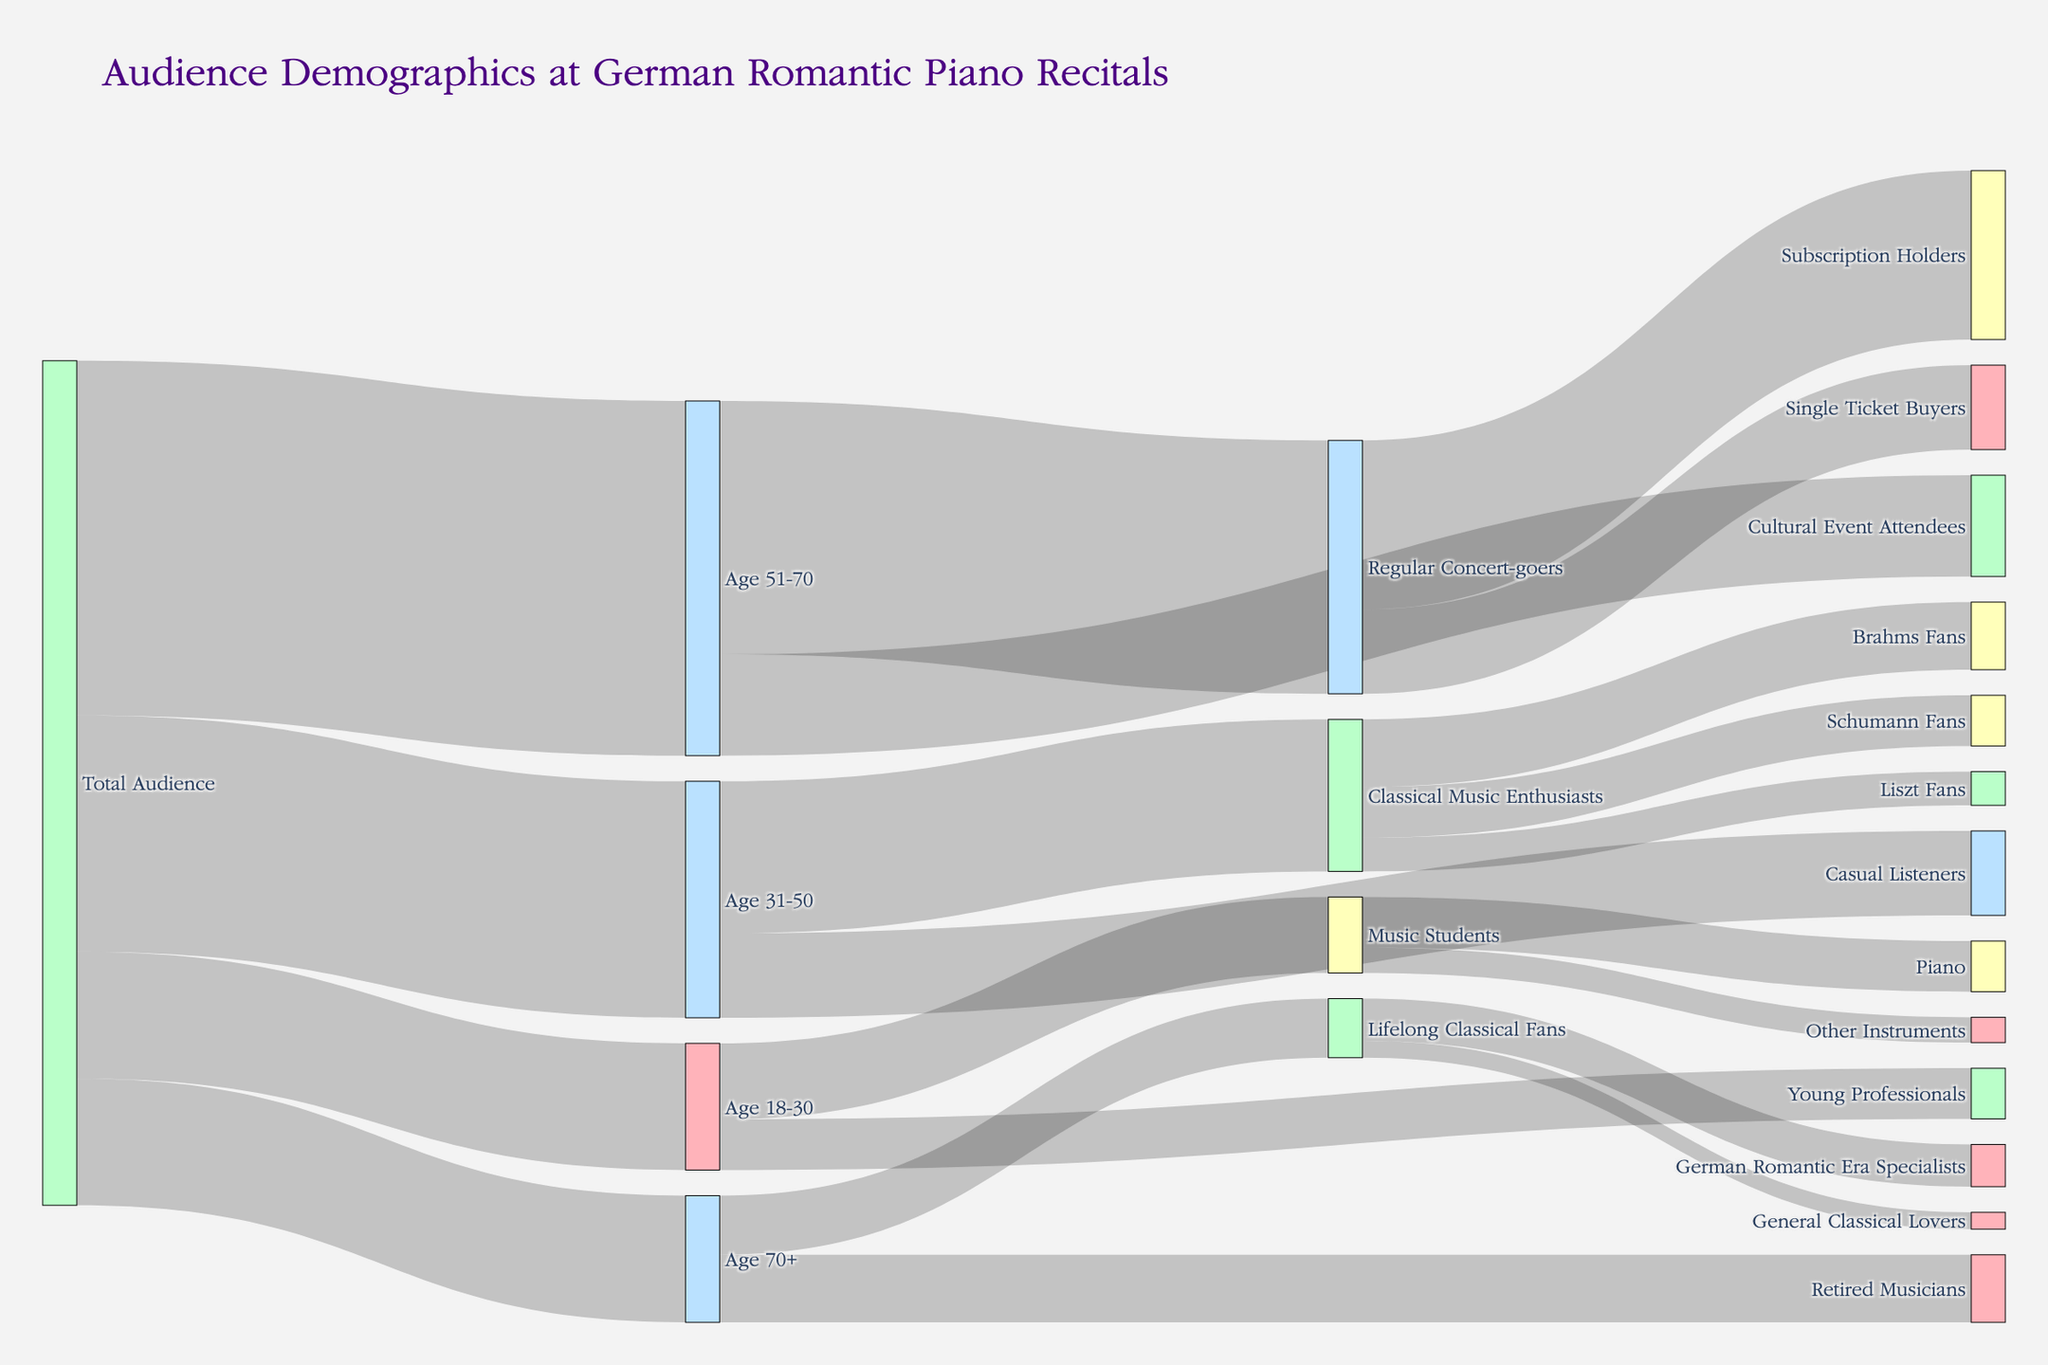What's the title of the diagram? Look at the top of the diagram where the title is usually placed. It reads "Audience Demographics at German Romantic Piano Recitals".
Answer: Audience Demographics at German Romantic Piano Recitals How many total audience members are there? The total audience members can be calculated by summing up all initial branches emanating from "Total Audience". These values are 150 + 280 + 420 + 150.
Answer: 1000 Which age group has the highest number of audience members? Examine the branches connected to "Total Audience" and compare their values. "Age 51-70" with a value of 420 has the highest.
Answer: Age 51-70 Among the "Age 31-50" group, which subgroup has more members: Classical Music Enthusiasts or Casual Listeners? Look at the branches emerging from "Age 31-50" and compare the values labeled "Classical Music Enthusiasts" (180) and "Casual Listeners" (100).
Answer: Classical Music Enthusiasts What is the sum of Music Students who play Piano and those who play other instruments? Look at the branches connected to "Music Students" and sum the values of "Piano" (60) and "Other Instruments" (30).
Answer: 90 Which specific subgroup within "Regular Concert-goers" has more members: Subscription Holders or Single Ticket Buyers? Compare the values of the branches emerging from "Regular Concert-goers", Subscription Holders have 200 and Single Ticket Buyers have 100.
Answer: Subscription Holders How many total Music Students are there aged between 18-30? The value of "Music Students" within the "Age 18-30" group is directly given as 90.
Answer: 90 What percentage of the "Age 18-30" group are Young Professionals? Take the number of Young Professionals (60) and divide by the total "Age 18-30" (150), then multiply by 100 to get the percentage. (60/150)*100 = 40%.
Answer: 40% How many Brahms Fans are there among Classical Music Enthusiasts? Look for the branch from "Classical Music Enthusiasts" that ends at "Brahms Fans" and note the value, which is 80.
Answer: 80 Which subgroup has more members: Lifelong Classical Fans or Retired Musicians within the Age 70+ group? Compare the values: Lifelong Classical Fans (70) and Retired Musicians (80). Retired Musicians have more members.
Answer: Retired Musicians 